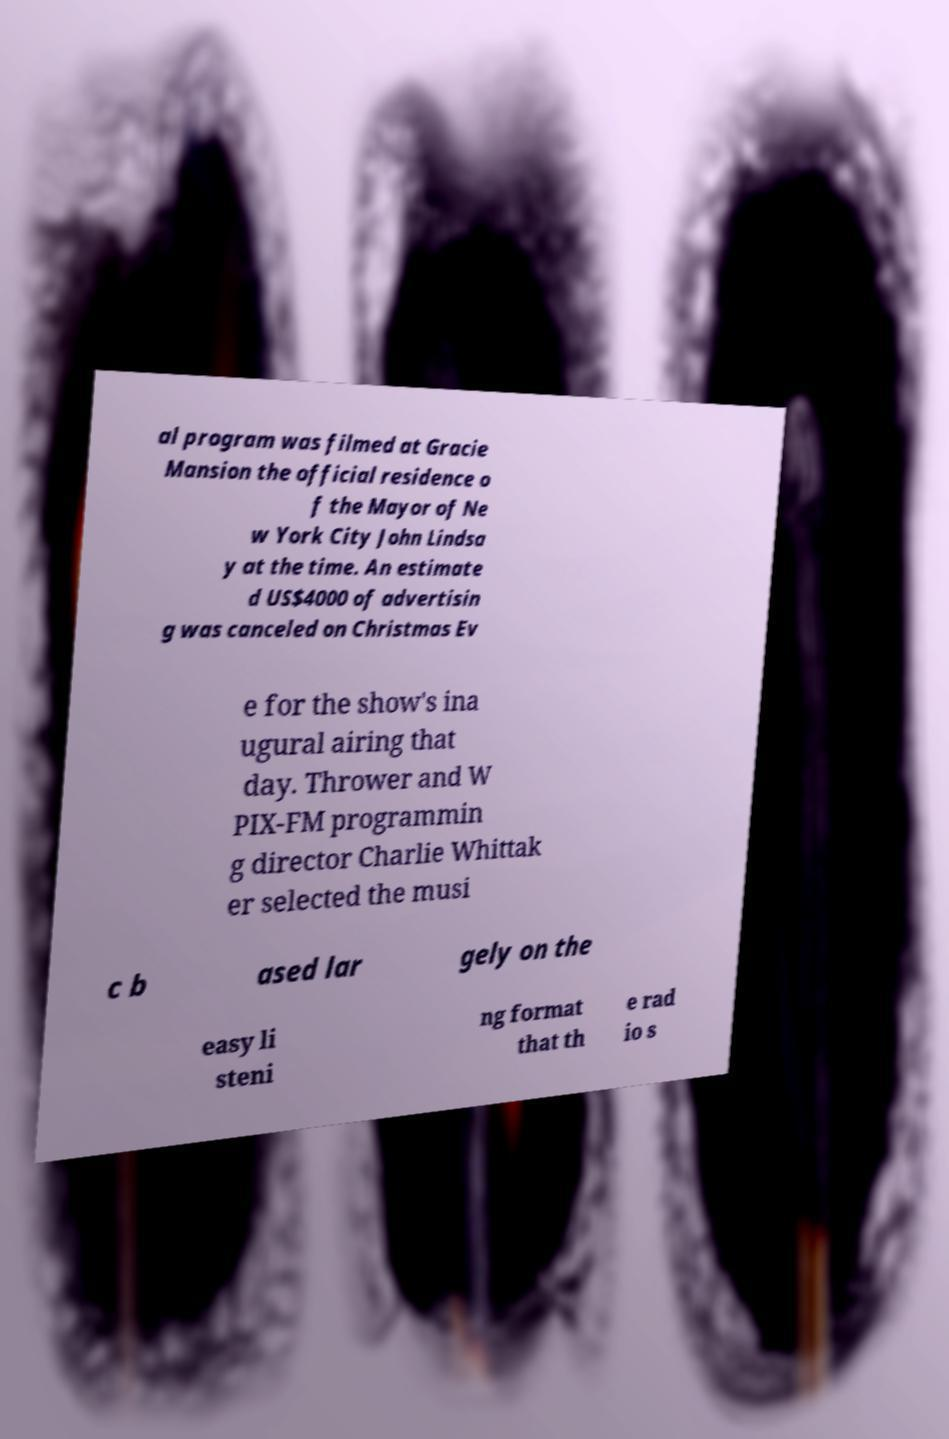Can you accurately transcribe the text from the provided image for me? al program was filmed at Gracie Mansion the official residence o f the Mayor of Ne w York City John Lindsa y at the time. An estimate d US$4000 of advertisin g was canceled on Christmas Ev e for the show's ina ugural airing that day. Thrower and W PIX-FM programmin g director Charlie Whittak er selected the musi c b ased lar gely on the easy li steni ng format that th e rad io s 